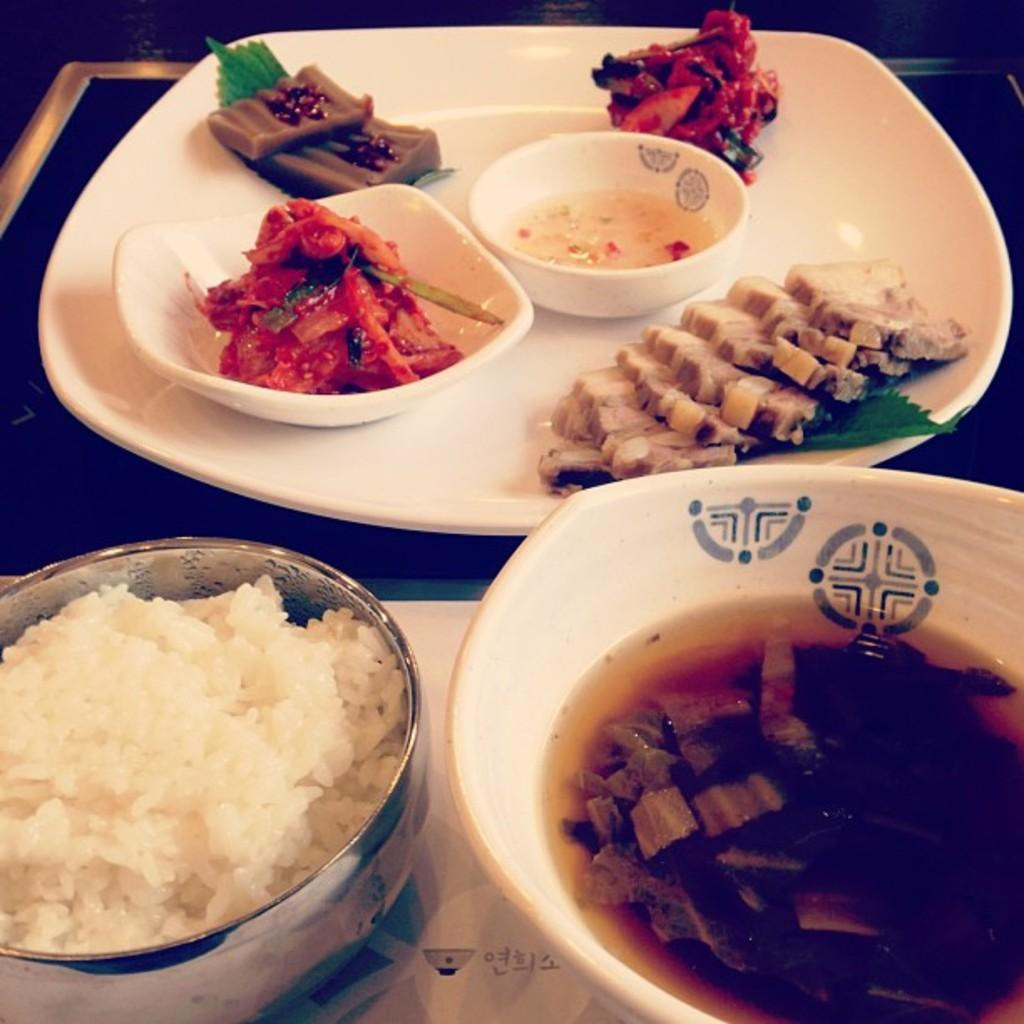What is located at the bottom of the image? There is a table at the bottom of the image. What objects are on the table? There are plates, bowls, and cups on the table. What type of food can be seen on the table? There is food on the table, including rice. Where is the doctor standing in the image? There is no doctor present in the image. What type of trees can be seen in the image? There are no trees visible in the image; it features a table with various objects on it. 